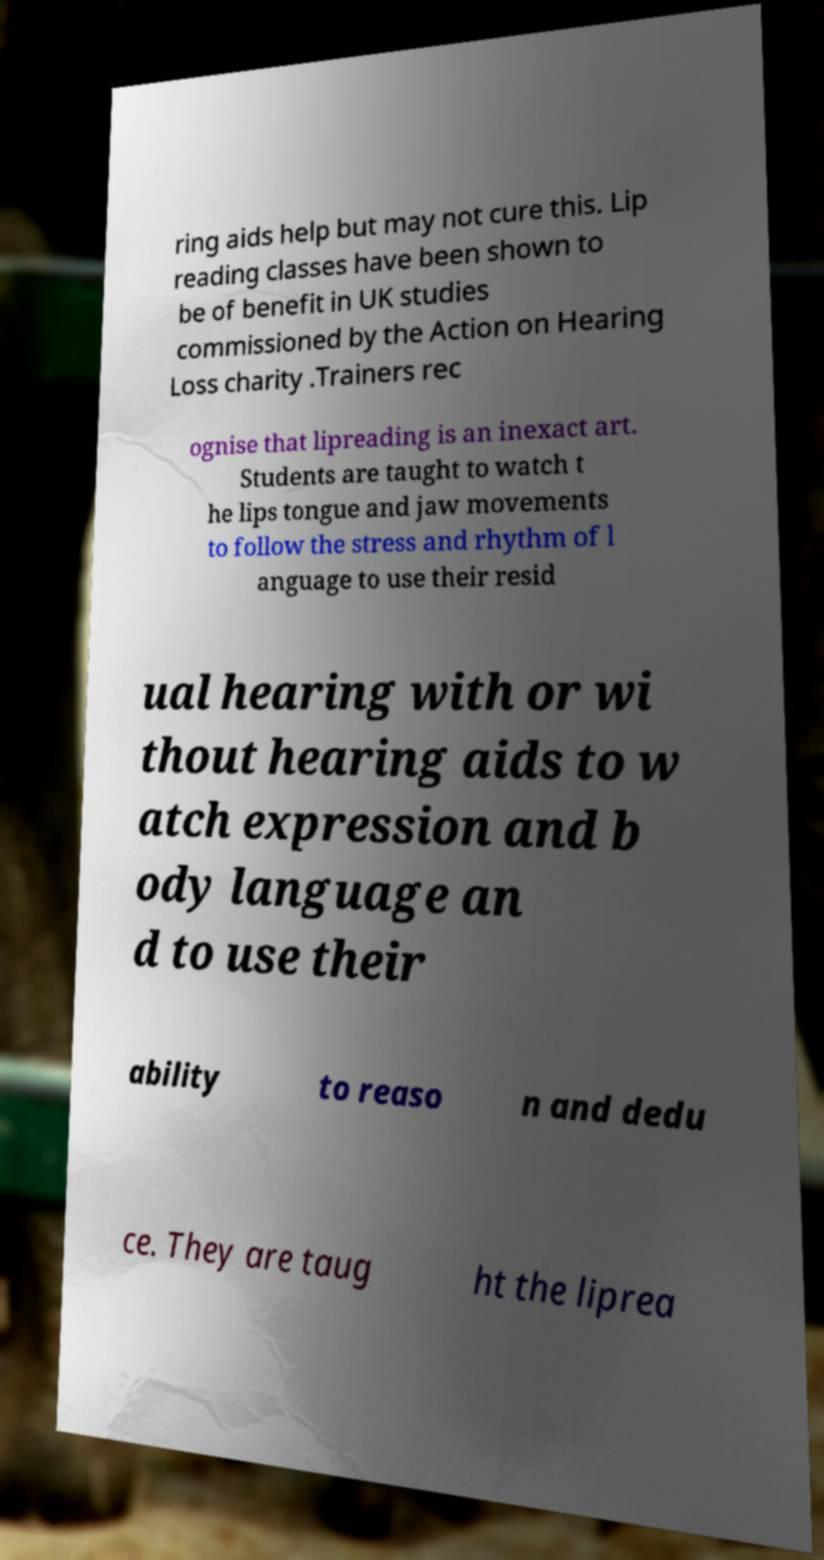What messages or text are displayed in this image? I need them in a readable, typed format. ring aids help but may not cure this. Lip reading classes have been shown to be of benefit in UK studies commissioned by the Action on Hearing Loss charity .Trainers rec ognise that lipreading is an inexact art. Students are taught to watch t he lips tongue and jaw movements to follow the stress and rhythm of l anguage to use their resid ual hearing with or wi thout hearing aids to w atch expression and b ody language an d to use their ability to reaso n and dedu ce. They are taug ht the liprea 